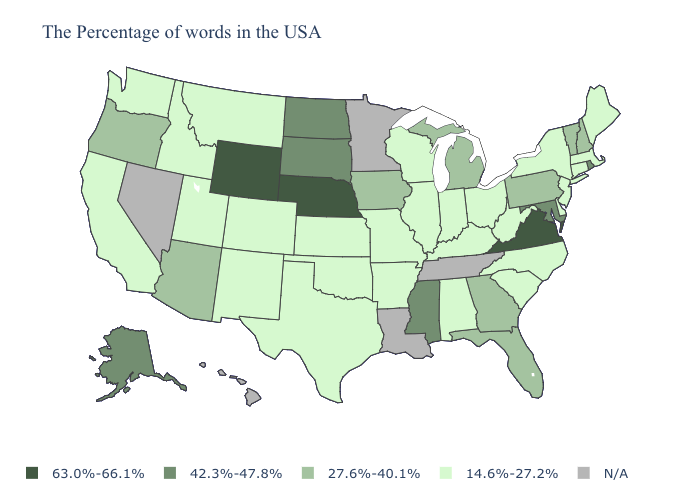What is the value of Michigan?
Answer briefly. 27.6%-40.1%. What is the highest value in the USA?
Quick response, please. 63.0%-66.1%. Name the states that have a value in the range 42.3%-47.8%?
Be succinct. Rhode Island, Maryland, Mississippi, South Dakota, North Dakota, Alaska. Which states have the highest value in the USA?
Write a very short answer. Virginia, Nebraska, Wyoming. What is the value of Montana?
Concise answer only. 14.6%-27.2%. What is the lowest value in the Northeast?
Quick response, please. 14.6%-27.2%. What is the value of Massachusetts?
Concise answer only. 14.6%-27.2%. What is the highest value in the Northeast ?
Keep it brief. 42.3%-47.8%. Among the states that border Massachusetts , which have the lowest value?
Give a very brief answer. Connecticut, New York. What is the value of Arizona?
Short answer required. 27.6%-40.1%. What is the value of North Carolina?
Be succinct. 14.6%-27.2%. Among the states that border Connecticut , does Massachusetts have the highest value?
Keep it brief. No. What is the value of New Mexico?
Keep it brief. 14.6%-27.2%. 